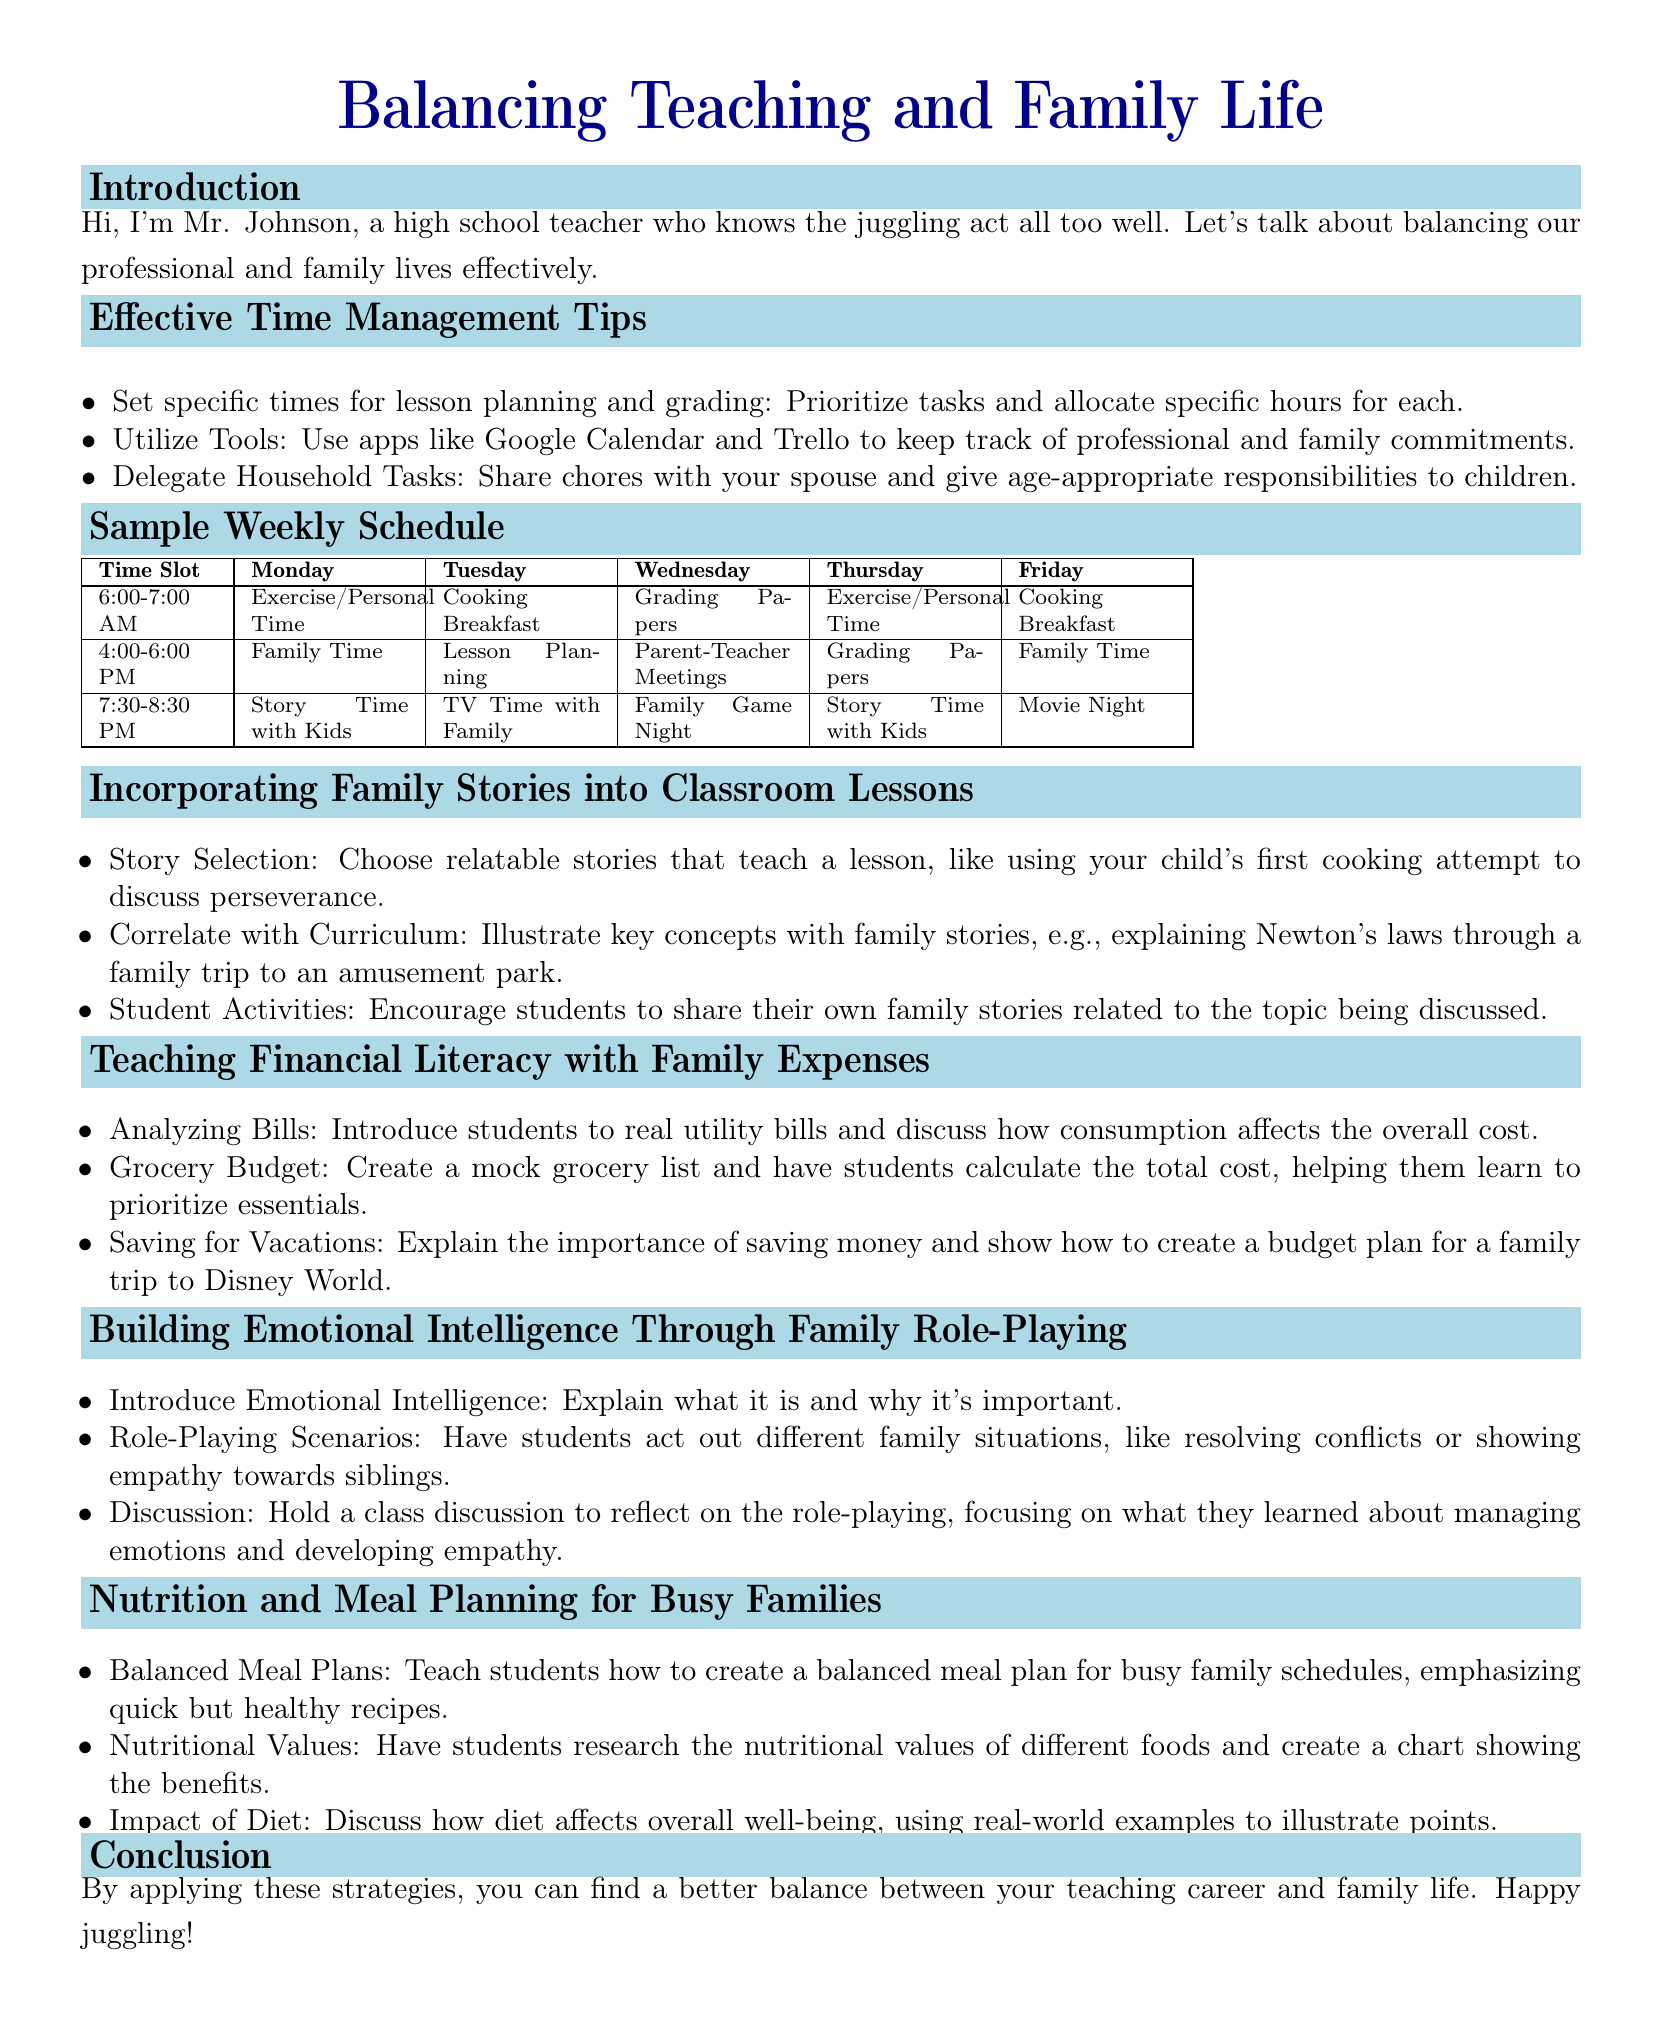What is the title of the lesson plan? The title of the lesson plan is prominently stated at the top of the document.
Answer: Balancing Teaching and Family Life Who is the author of the lesson plan? The introduction section includes the author's name and role as a teacher.
Answer: Mr. Johnson What tool is suggested for keeping track of commitments? The document provides a suggestion for tools in the time management tips section.
Answer: Google Calendar On which day is Family Game Night scheduled? The sample weekly schedule specifies the evening activity for one of the weekdays.
Answer: Wednesday What topic correlates family stories with curriculum lessons? The lesson plan describes a specific aspect of how to enhance classroom engagement.
Answer: Incorporating Family Stories into Classroom Lessons How many hours are dedicated to Family Time on Tuesday? The weekly schedule indicates the time allocated for family activities on that day.
Answer: 2 hours What is the first step in teaching financial literacy? The document outlines a specific activity recommended for students regarding expenses.
Answer: Analyzing Bills What is one activity included in the emotional intelligence section? The section discusses role-playing exercises to enhance understanding among students.
Answer: Role-Playing Scenarios What is the focus of the nutrition lesson plan? The lesson plan outlines important elements related to health and diet for families.
Answer: Meal Planning for Busy Families 